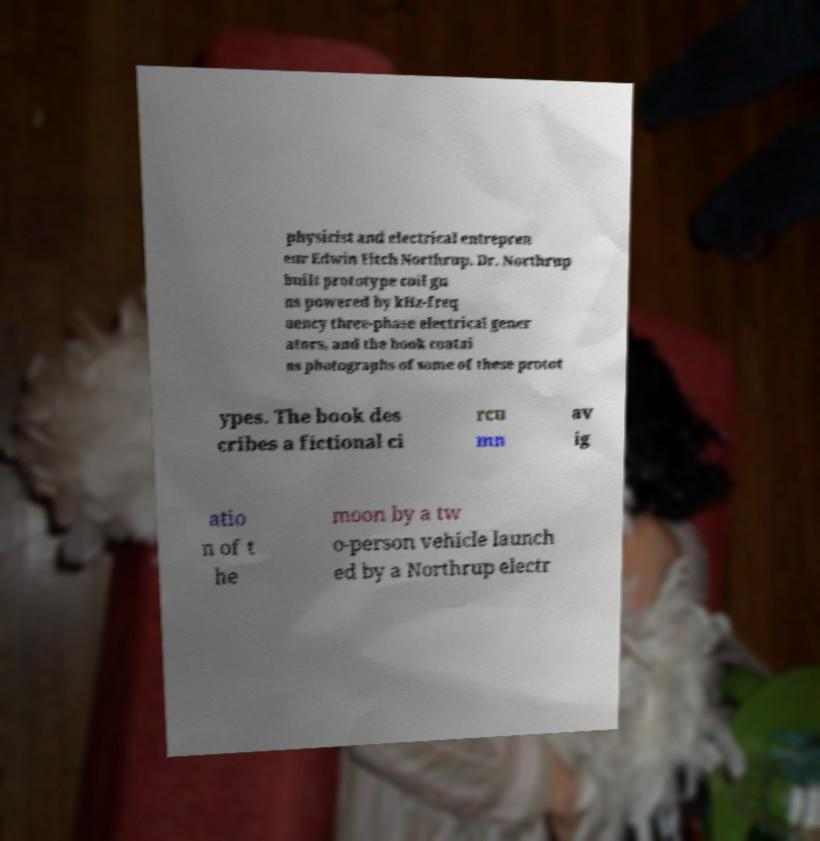Could you assist in decoding the text presented in this image and type it out clearly? physicist and electrical entrepren eur Edwin Fitch Northrup. Dr. Northrup built prototype coil gu ns powered by kHz-freq uency three-phase electrical gener ators, and the book contai ns photographs of some of these protot ypes. The book des cribes a fictional ci rcu mn av ig atio n of t he moon by a tw o-person vehicle launch ed by a Northrup electr 